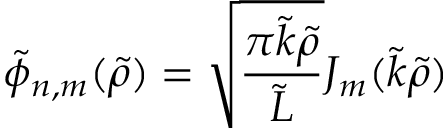Convert formula to latex. <formula><loc_0><loc_0><loc_500><loc_500>\tilde { \phi } _ { n , m } ( \tilde { \rho } ) = \sqrt { \frac { \pi \tilde { k } \tilde { \rho } } { \tilde { L } } } J _ { m } ( \tilde { k } \tilde { \rho } )</formula> 